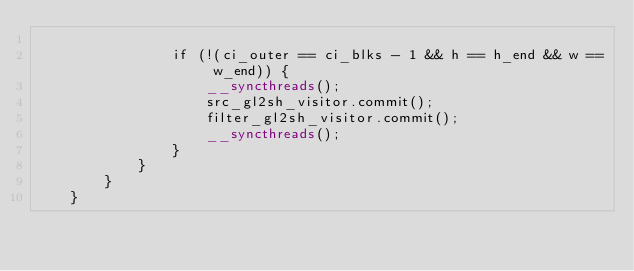Convert code to text. <code><loc_0><loc_0><loc_500><loc_500><_Cuda_>
                if (!(ci_outer == ci_blks - 1 && h == h_end && w == w_end)) {
                    __syncthreads();
                    src_gl2sh_visitor.commit();
                    filter_gl2sh_visitor.commit();
                    __syncthreads();
                }
            }
        }
    }
</code> 